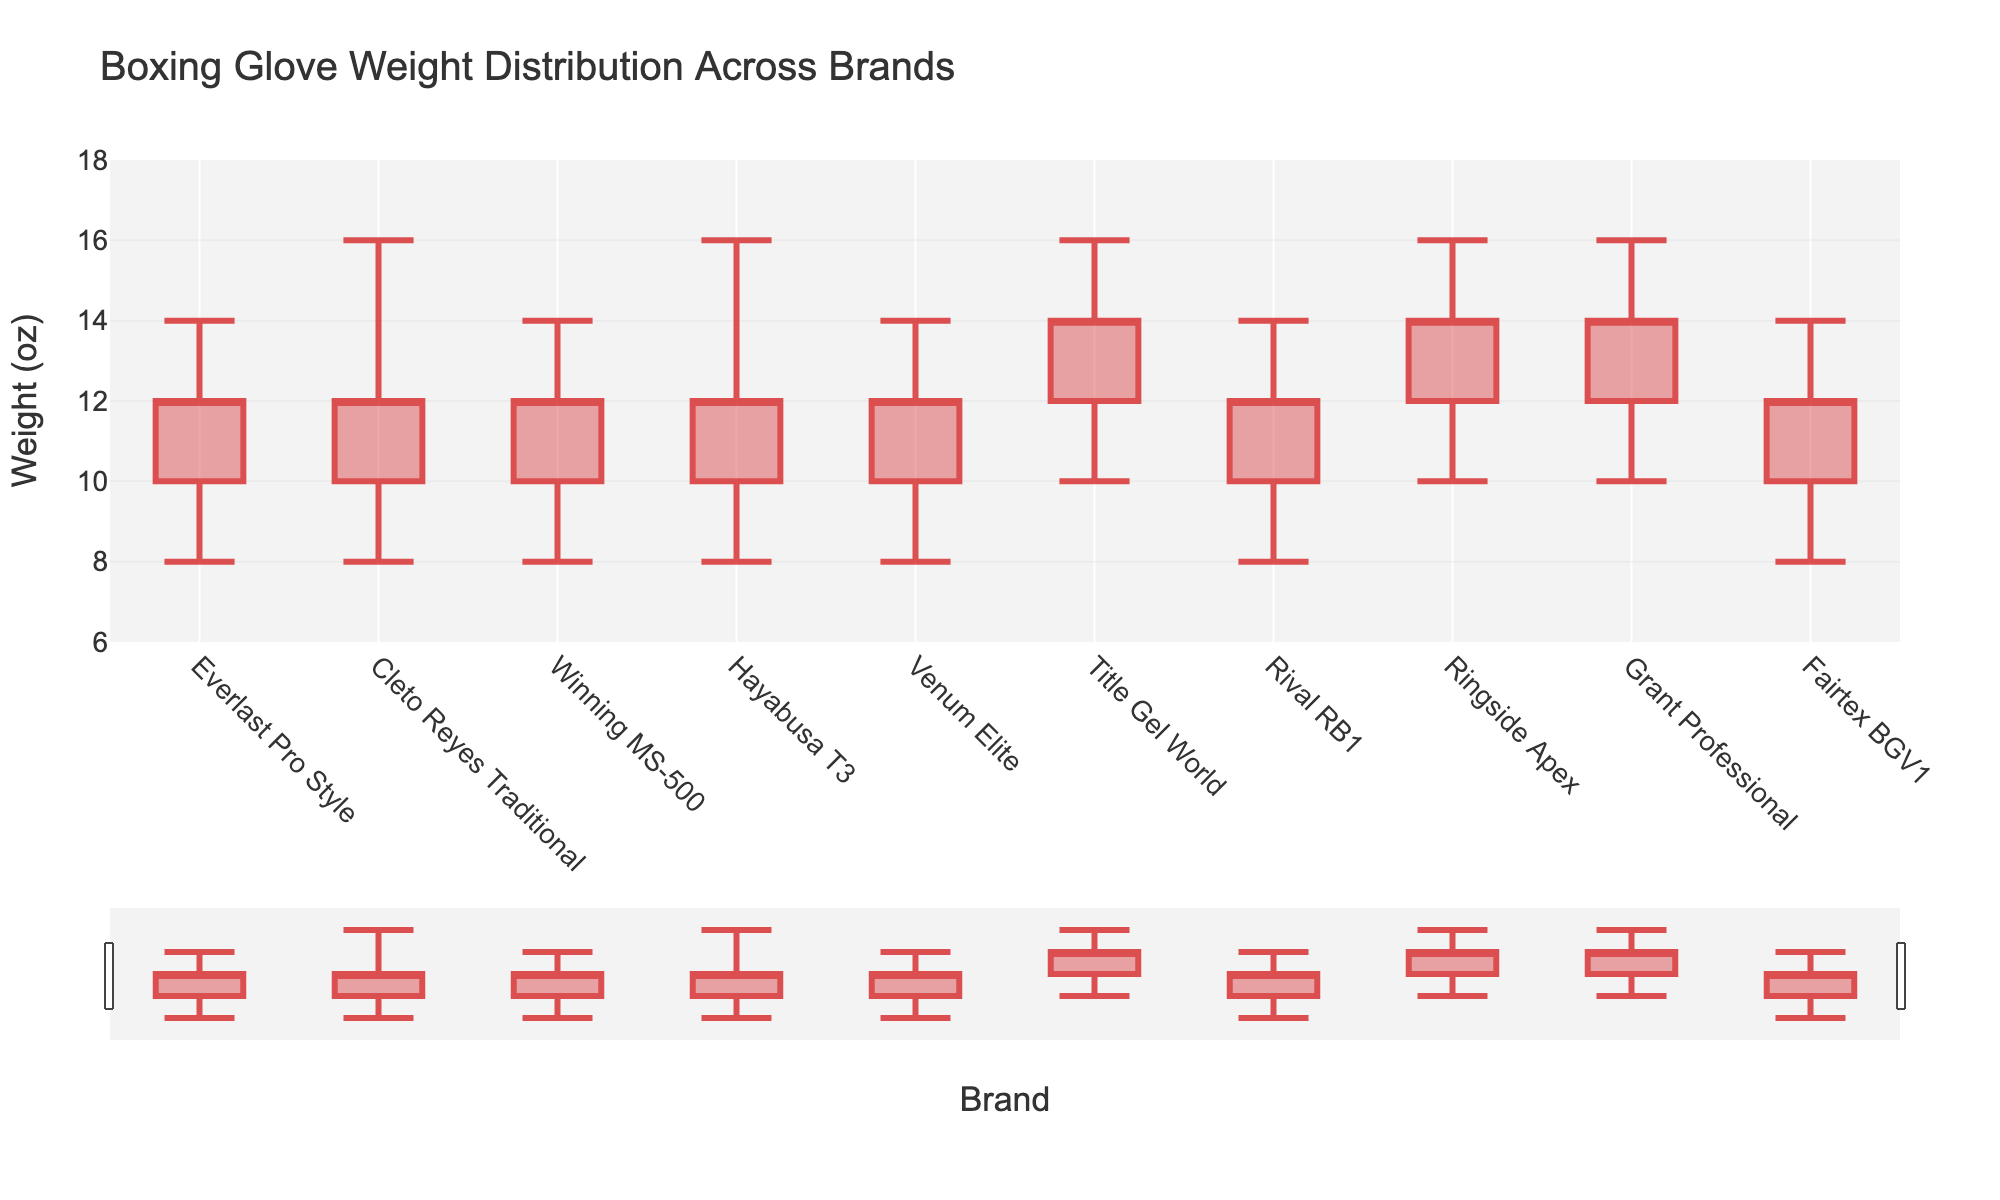What's the title of the chart? The title of the chart is displayed at the top.
Answer: Boxing Glove Weight Distribution Across Brands Which brand has the highest value on the High axis? The highest value on the High axis is 16, which can be seen for several brands including Cleto Reyes Traditional, Hayabusa T3, Title Gel World, Ringside Apex, and Grant Professional.
Answer: Cleto Reyes Traditional, Hayabusa T3, Title Gel World, Ringside Apex, Grant Professional For which brand is the Close value greater than the Open value? By comparing the Close and Open columns for each brand, we can see that none of the brands show the Close value greater than the Open value since all have the same values.
Answer: None What's the Open value for Everlast Pro Style? The Open value for Everlast Pro Style is the value situated at the start of the bar chart for this brand, which is 10.
Answer: 10 Which brands have the same range between the Low and High values? To determine this, we calculate the range (High - Low) for each brand and compare them. Several brands, such as Everlast Pro Style and Fairtex BGV1, have a range of 6 (14-8).
Answer: Everlast Pro Style, Winning MS-500, Venum Elite, Rival RB1, Fairtex BGV1 Which brand has the lowest Open value? By examining the Open values across all brands, the brands with the lowest Open value of 10 include Everlast Pro Style, Cleto Reyes Traditional, Winning MS-500, Hayabusa T3, Venum Elite, Rival RB1, and Fairtex BGV1.
Answer: Everlast Pro Style, Cleto Reyes Traditional, Winning MS-500, Hayabusa T3, Venum Elite, Rival RB1, Fairtex BGV1 What’s the median High value across all brands? To find the median High value, we list all High values (14, 16, 14, 16, 14, 16, 14, 16, 16, 14) in ascending order, the middle value (fifth and sixth) is 14 and 16, thus the median value is (14+16)/2 = 15.
Answer: 15 Which brand has the widest range between its Low and High values? The range for each brand is calculated by subtracting the Low value from the High value, and the brand with the widest range is Cleto Reyes Traditional and Hayabusa T3 (16-8 = 8).
Answer: Cleto Reyes Traditional, Hayabusa T3 Which brand has a Close value equal to its High value? The Close value for each brand can be compared with its corresponding High value, and Title Gel World is the brand where the Close value (16) equals the High value (16).
Answer: Title Gel World 